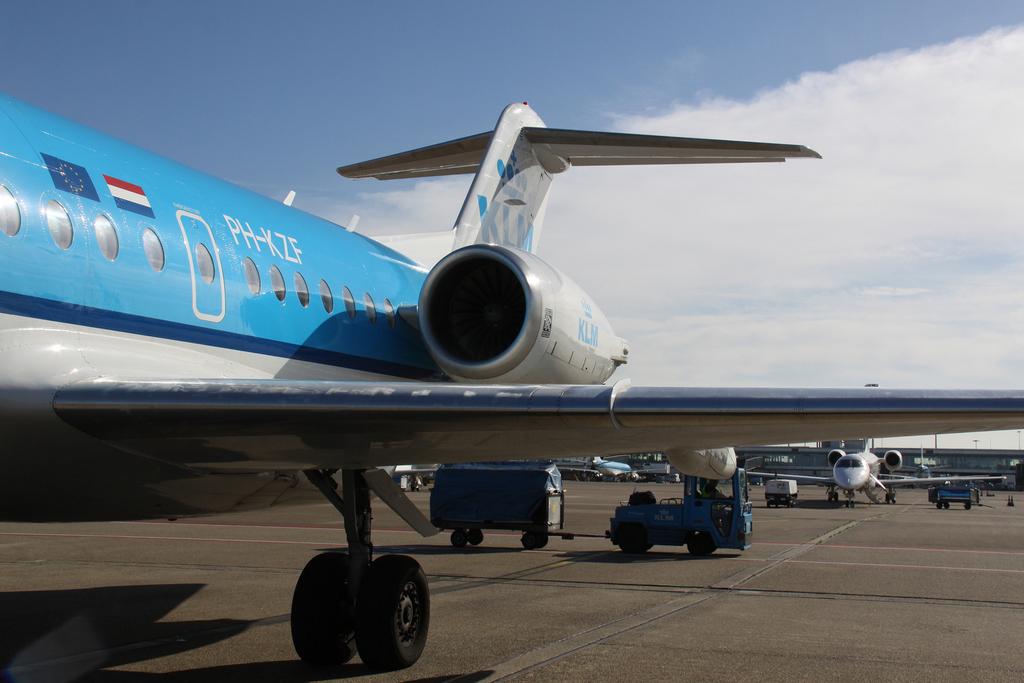What plane is this?
Offer a terse response. Ph-kzf. Is this a klm plane?
Keep it short and to the point. Yes. 